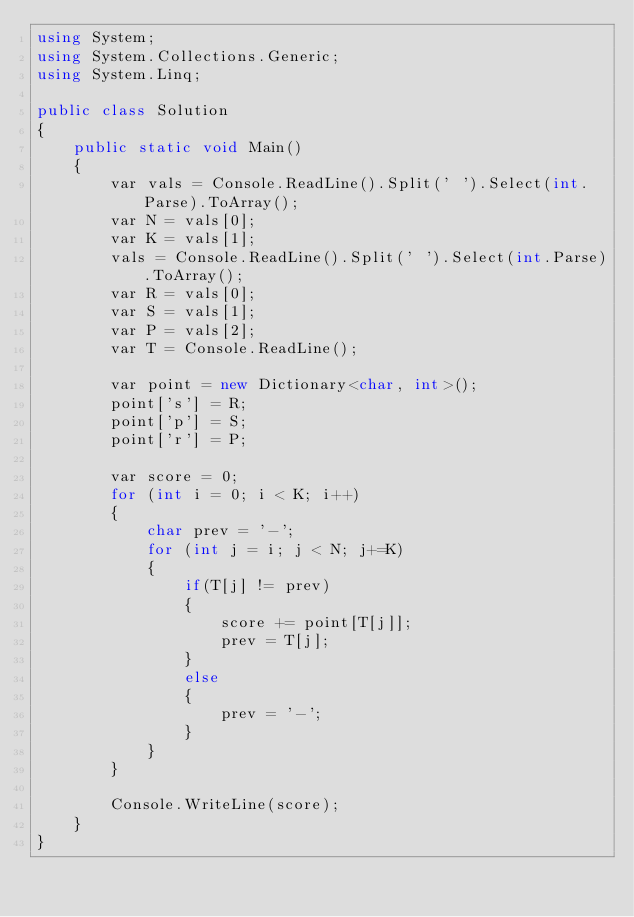<code> <loc_0><loc_0><loc_500><loc_500><_C#_>using System;
using System.Collections.Generic;
using System.Linq;

public class Solution
{
    public static void Main()
    {
        var vals = Console.ReadLine().Split(' ').Select(int.Parse).ToArray();
        var N = vals[0];
        var K = vals[1];
        vals = Console.ReadLine().Split(' ').Select(int.Parse).ToArray();
        var R = vals[0];
        var S = vals[1];
        var P = vals[2];
        var T = Console.ReadLine();

        var point = new Dictionary<char, int>();
        point['s'] = R;
        point['p'] = S;
        point['r'] = P;

        var score = 0;
        for (int i = 0; i < K; i++)
        {
            char prev = '-';
            for (int j = i; j < N; j+=K)
            {
                if(T[j] != prev)
                {
                    score += point[T[j]];
                    prev = T[j];
                }
                else
                {
                    prev = '-';
                }
            }
        }

        Console.WriteLine(score);
    }
}</code> 